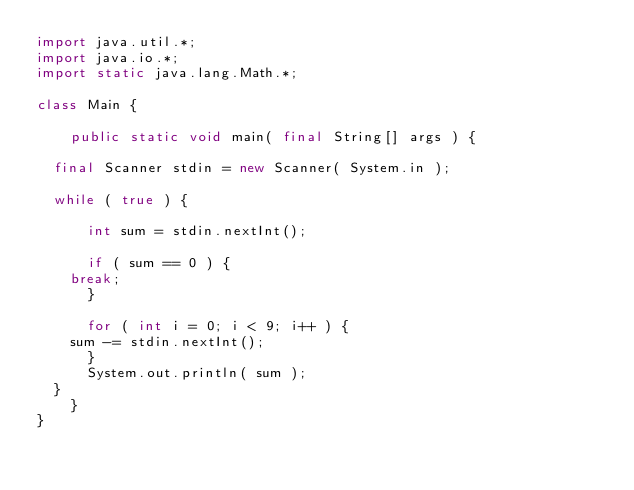Convert code to text. <code><loc_0><loc_0><loc_500><loc_500><_Java_>import java.util.*;
import java.io.*;
import static java.lang.Math.*;

class Main {

    public static void main( final String[] args ) {

	final Scanner stdin = new Scanner( System.in );

	while ( true ) {

	    int sum = stdin.nextInt();

	    if ( sum == 0 ) {
		break;
	    }

	    for ( int i = 0; i < 9; i++ ) {
		sum -= stdin.nextInt();
	    }
	    System.out.println( sum );
	}	
    }    
}</code> 